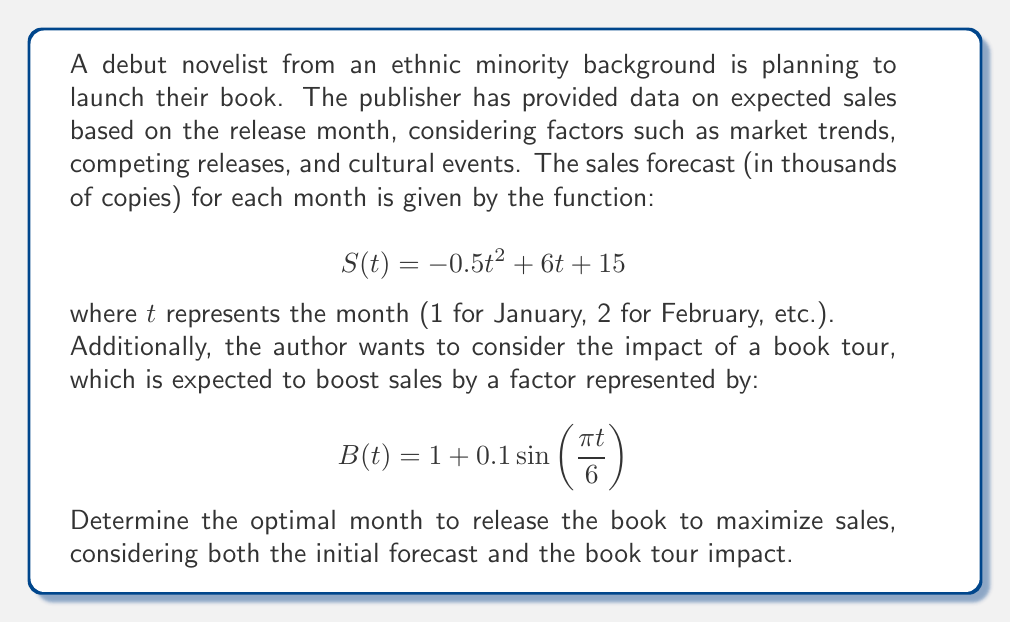Solve this math problem. To solve this optimization problem, we need to follow these steps:

1) First, we need to create a combined function that represents total sales, including the book tour impact:

   $$T(t) = S(t) \cdot B(t)$$

2) Expanding this function:

   $$T(t) = (-0.5t^2 + 6t + 15) \cdot (1 + 0.1\sin(\frac{\pi t}{6}))$$

3) To find the maximum of this function, we need to find where its derivative equals zero. However, this function is complex, so we'll use a numerical approach.

4) We'll evaluate $T(t)$ for each month (t = 1 to 12) and find the maximum:

   For t = 1: $T(1) = 20.5 \cdot 1.05 = 21.525$
   For t = 2: $T(2) = 25 \cdot 1.087 = 27.175$
   For t = 3: $T(3) = 28.5 \cdot 1.1 = 31.35$
   For t = 4: $T(4) = 31 \cdot 1.087 = 33.697$
   For t = 5: $T(5) = 32.5 \cdot 1.05 = 34.125$
   For t = 6: $T(6) = 33 \cdot 1 = 33$
   For t = 7: $T(7) = 32.5 \cdot 0.95 = 30.875$
   For t = 8: $T(8) = 31 \cdot 0.913 = 28.303$
   For t = 9: $T(9) = 28.5 \cdot 0.9 = 25.65$
   For t = 10: $T(10) = 25 \cdot 0.913 = 22.825$
   For t = 11: $T(11) = 20.5 \cdot 0.95 = 19.475$
   For t = 12: $T(12) = 15 \cdot 1 = 15$

5) The maximum value occurs when t = 5, which corresponds to May.
Answer: The optimal month to release the book is May (t = 5), which is expected to result in maximum sales of approximately 34,125 copies. 